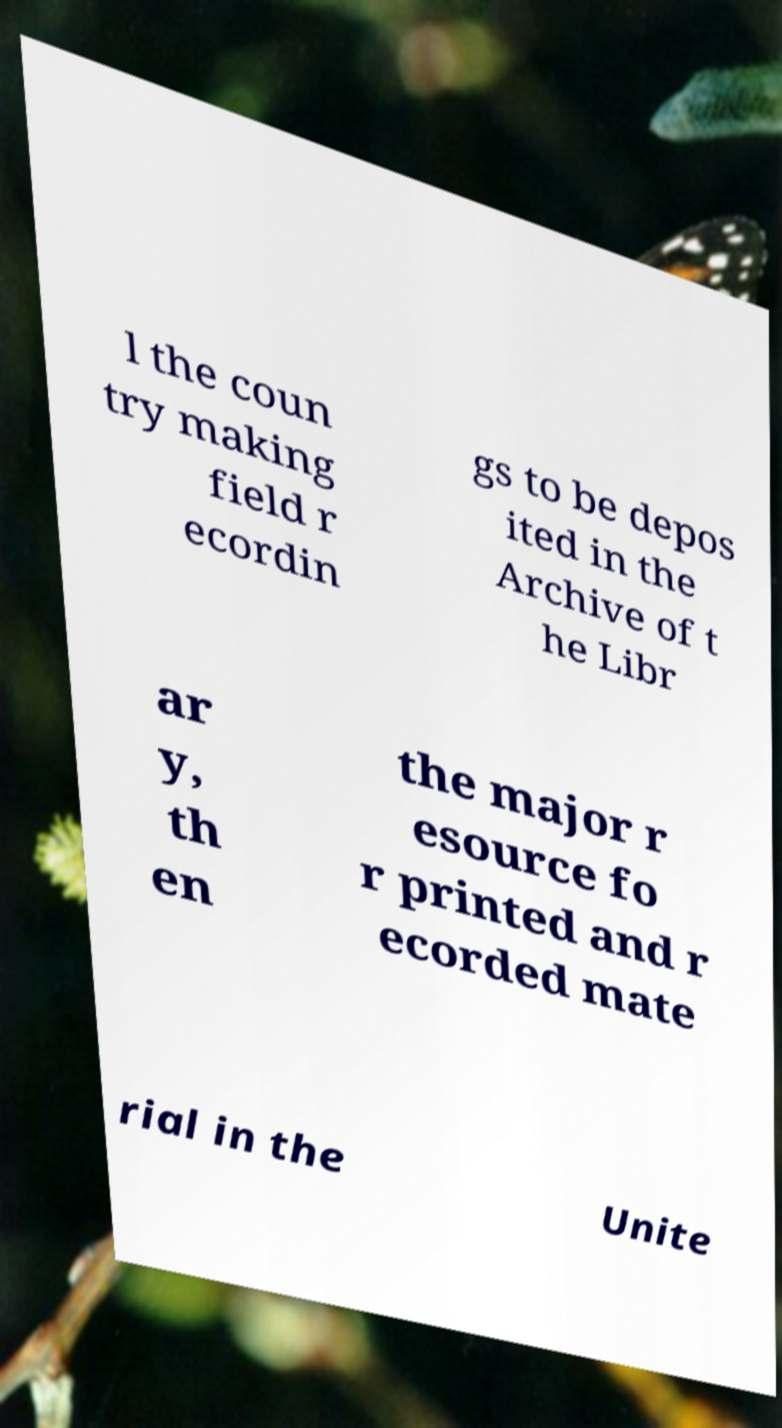Can you accurately transcribe the text from the provided image for me? l the coun try making field r ecordin gs to be depos ited in the Archive of t he Libr ar y, th en the major r esource fo r printed and r ecorded mate rial in the Unite 